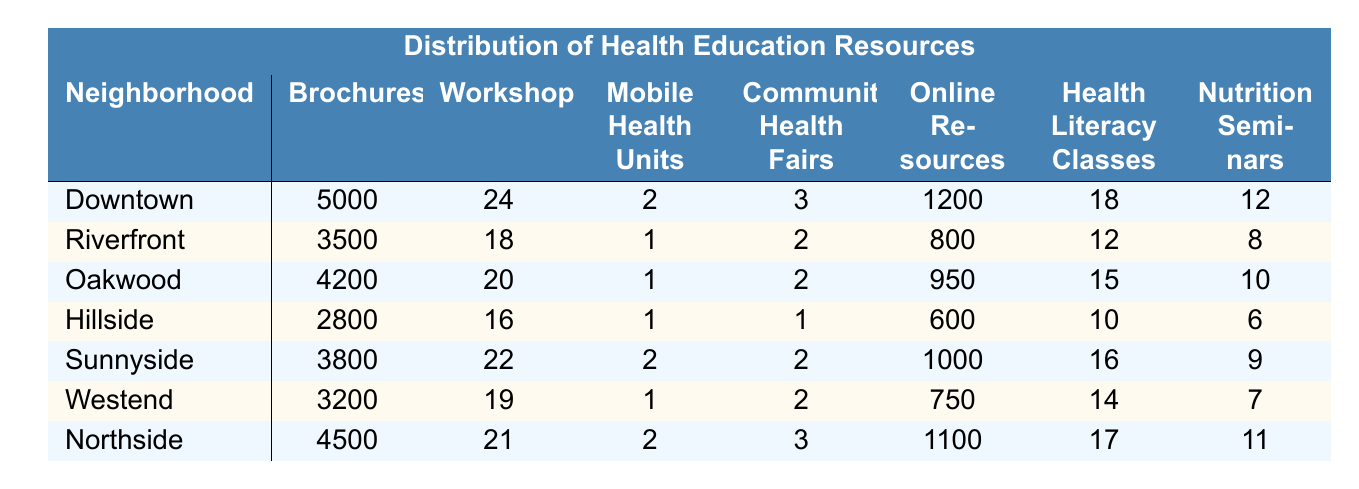What neighborhood has the highest number of brochures? Looking at the table, Downtown has the highest number of brochures with a total of 5000.
Answer: Downtown How many health literacy classes are offered in Northside? The table shows that Northside has 17 health literacy classes available.
Answer: 17 Which neighborhood has the lowest number of mobile health units? Hillside has the lowest number of mobile health units, with just 1 unit available.
Answer: Hillside What is the total number of workshops held across all neighborhoods? Summing the workshops from each neighborhood: 24 + 18 + 20 + 16 + 22 + 19 + 21 = 140.
Answer: 140 Is it true that Riverfront has more online resources than Hillside? Yes, Riverfront has 800 online resources while Hillside has only 600.
Answer: Yes Which neighborhood has more community health fairs, Northside or Sunnyside? Northside has 3 community health fairs while Sunnyside has only 2, so Northside has more.
Answer: Northside What is the average number of nutrition seminars offered across all neighborhoods? The total number of nutrition seminars is 12 + 8 + 10 + 6 + 9 + 7 + 11 = 63. There are 7 neighborhoods, so the average is 63/7 = 9.
Answer: 9 Which neighborhood has the closest number of online resources to Oakwood? Oakwood has 950 online resources, and the closest to that is Northside with 1100 online resources.
Answer: Northside 